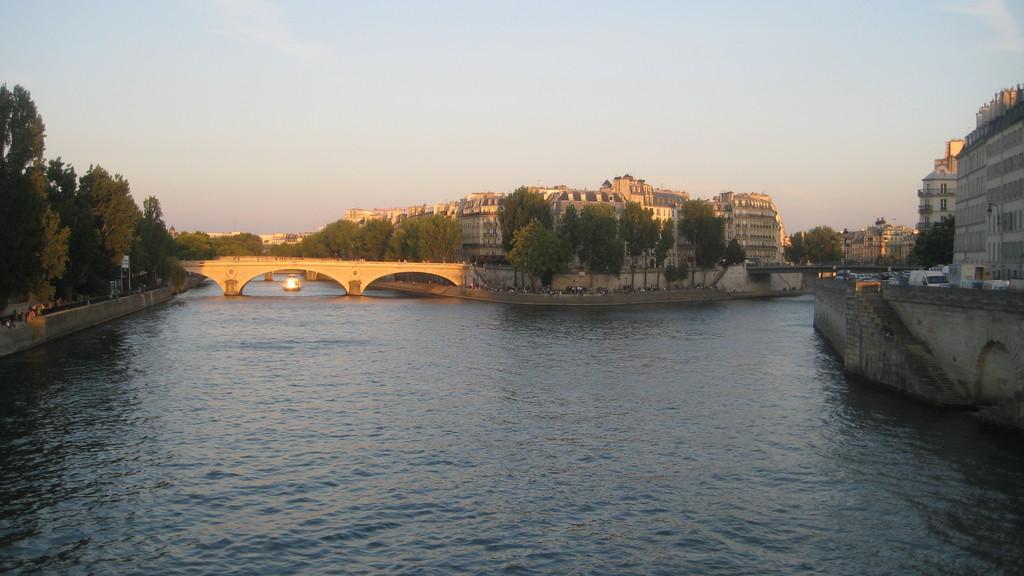In one or two sentences, can you explain what this image depicts? In this image there is a river and there is a ship floating, above the river there is a bridge. In the background there are trees, buildings, moving vehicles on the road and the sky. 